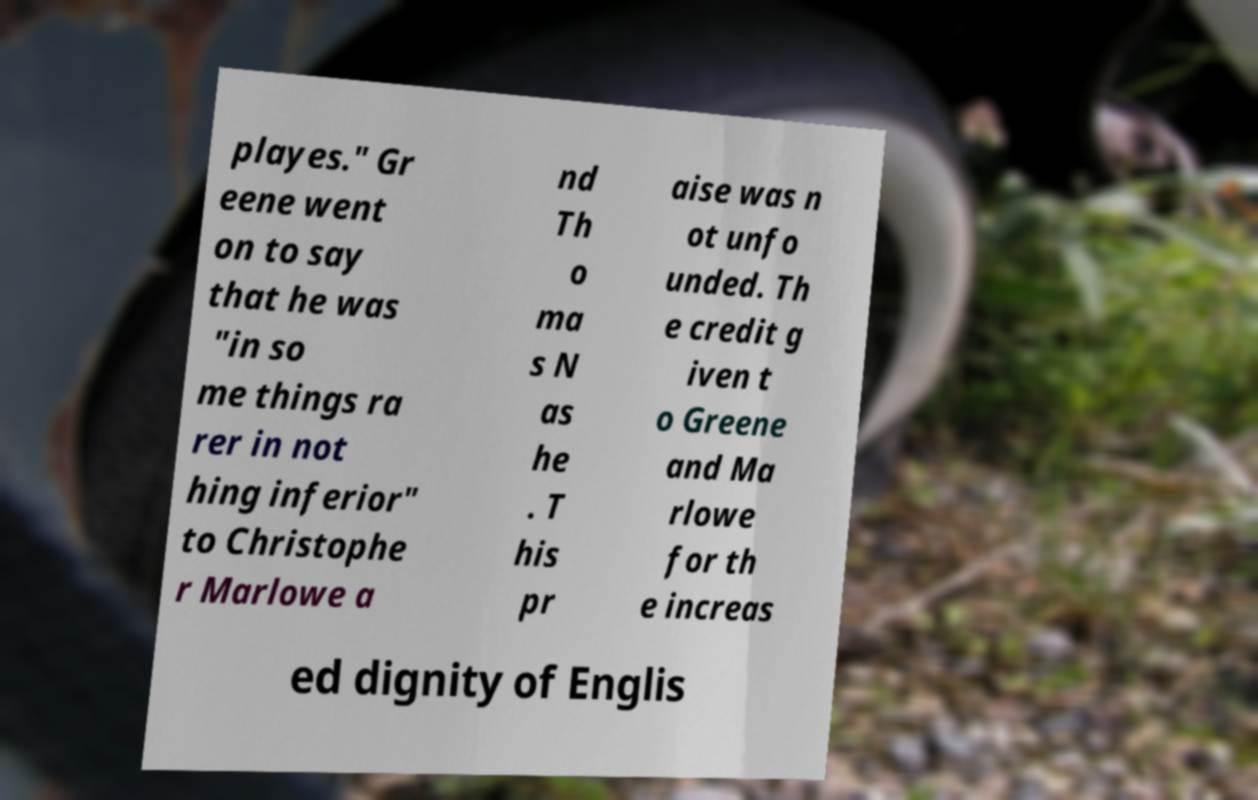There's text embedded in this image that I need extracted. Can you transcribe it verbatim? playes." Gr eene went on to say that he was "in so me things ra rer in not hing inferior" to Christophe r Marlowe a nd Th o ma s N as he . T his pr aise was n ot unfo unded. Th e credit g iven t o Greene and Ma rlowe for th e increas ed dignity of Englis 